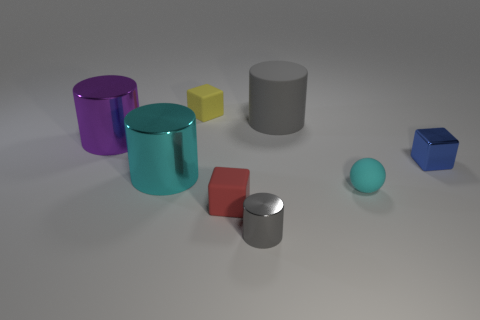How many things are large gray things or small yellow rubber blocks?
Offer a terse response. 2. Is there any other thing that is the same color as the tiny metal cube?
Your answer should be compact. No. Is the material of the tiny cyan object the same as the red object that is in front of the matte cylinder?
Your answer should be compact. Yes. What is the shape of the red object behind the metal thing in front of the large cyan metallic thing?
Provide a short and direct response. Cube. There is a object that is to the right of the large cyan cylinder and to the left of the red thing; what shape is it?
Your response must be concise. Cube. How many objects are cyan cubes or small objects that are to the right of the cyan cylinder?
Provide a succinct answer. 5. What is the material of the blue object that is the same shape as the tiny yellow thing?
Offer a terse response. Metal. There is a thing that is both behind the large purple object and on the left side of the big gray rubber cylinder; what material is it?
Ensure brevity in your answer.  Rubber. How many tiny cyan things are the same shape as the purple thing?
Provide a short and direct response. 0. There is a small shiny object on the right side of the big object that is on the right side of the small yellow object; what color is it?
Provide a succinct answer. Blue. 